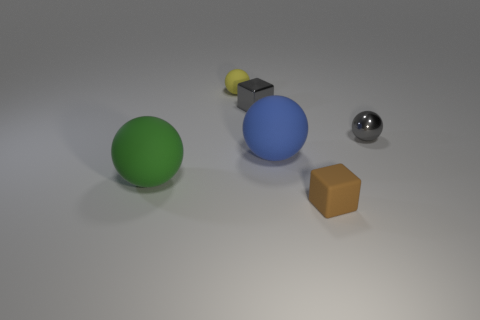Subtract all gray spheres. How many spheres are left? 3 Add 3 gray balls. How many objects exist? 9 Subtract all green spheres. How many spheres are left? 3 Subtract all blocks. How many objects are left? 4 Subtract all big shiny cylinders. Subtract all tiny gray metal cubes. How many objects are left? 5 Add 3 small gray shiny things. How many small gray shiny things are left? 5 Add 6 big green matte things. How many big green matte things exist? 7 Subtract 0 yellow cylinders. How many objects are left? 6 Subtract 2 balls. How many balls are left? 2 Subtract all blue spheres. Subtract all blue cylinders. How many spheres are left? 3 